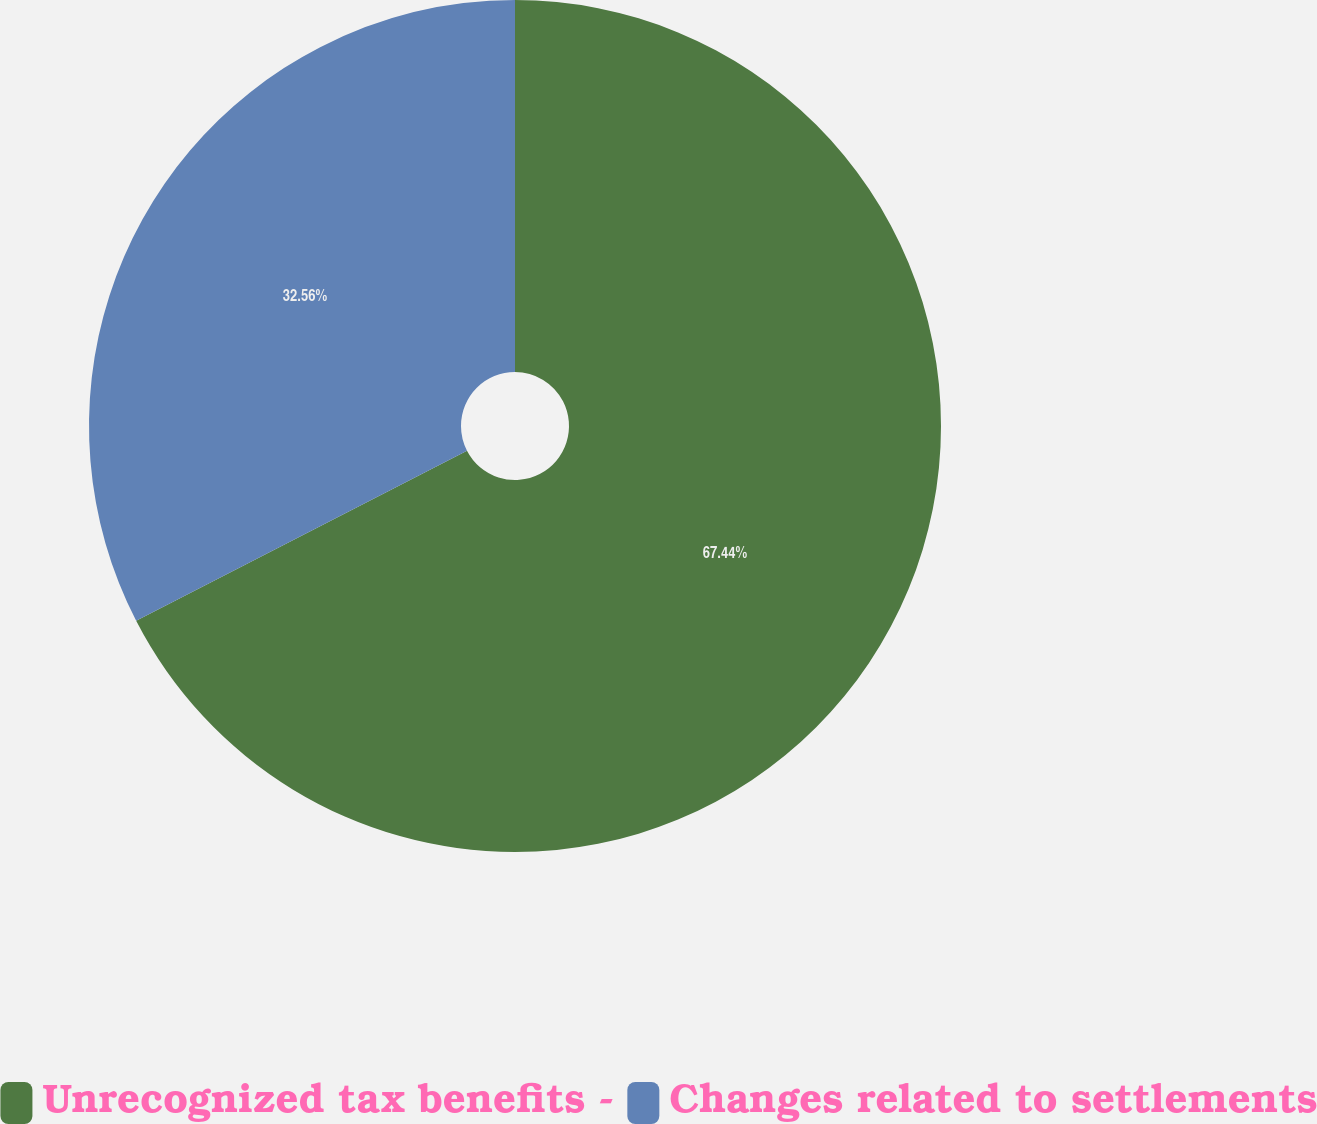Convert chart. <chart><loc_0><loc_0><loc_500><loc_500><pie_chart><fcel>Unrecognized tax benefits -<fcel>Changes related to settlements<nl><fcel>67.44%<fcel>32.56%<nl></chart> 